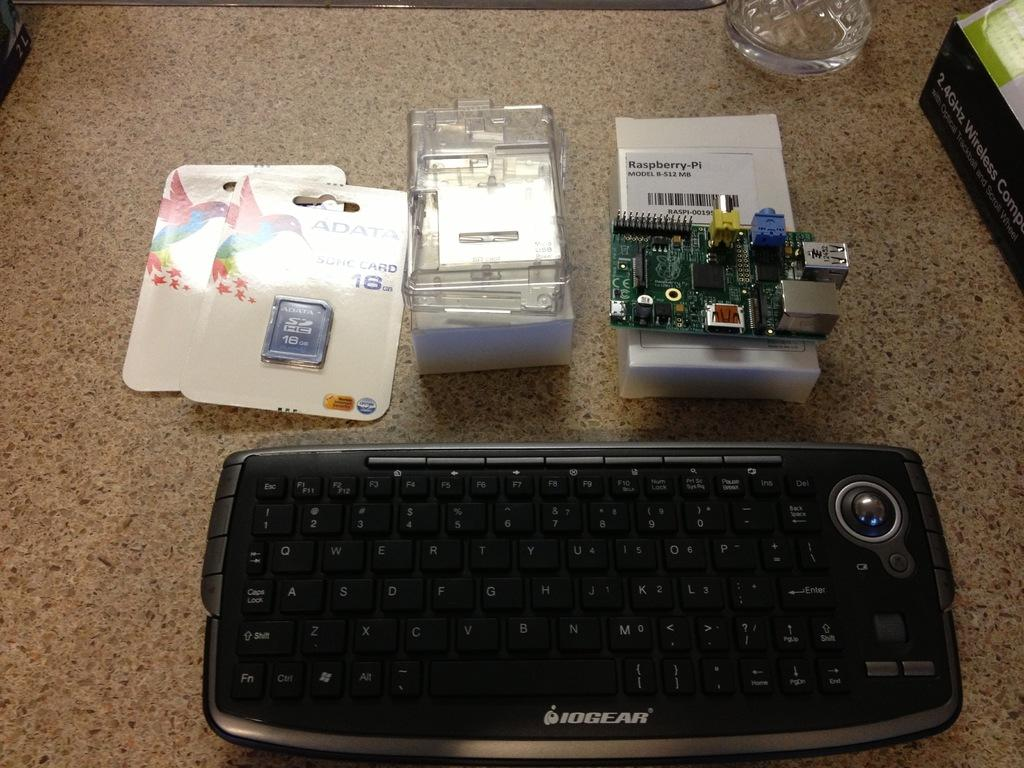<image>
Describe the image concisely. An Iogear computer keyboard sits next to three packages. 